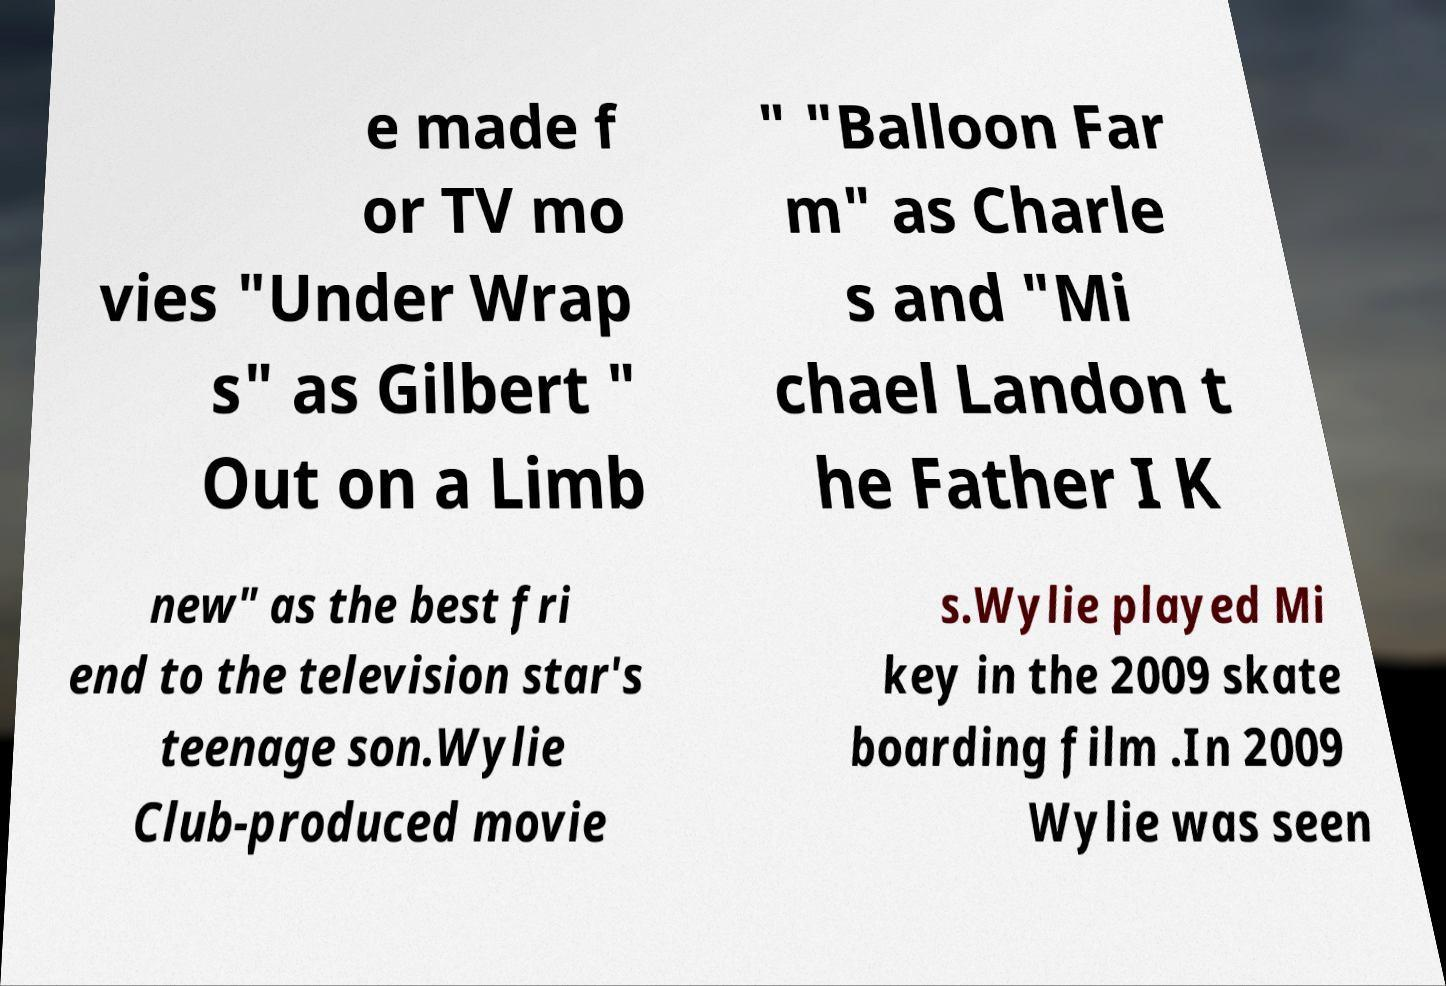Can you read and provide the text displayed in the image?This photo seems to have some interesting text. Can you extract and type it out for me? e made f or TV mo vies "Under Wrap s" as Gilbert " Out on a Limb " "Balloon Far m" as Charle s and "Mi chael Landon t he Father I K new" as the best fri end to the television star's teenage son.Wylie Club-produced movie s.Wylie played Mi key in the 2009 skate boarding film .In 2009 Wylie was seen 